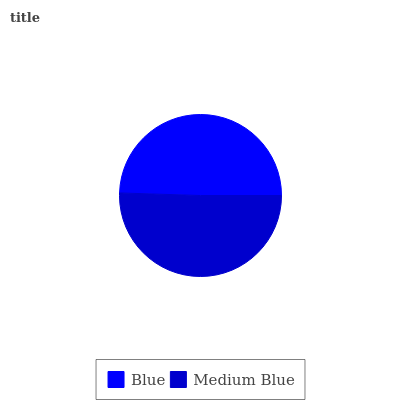Is Blue the minimum?
Answer yes or no. Yes. Is Medium Blue the maximum?
Answer yes or no. Yes. Is Medium Blue the minimum?
Answer yes or no. No. Is Medium Blue greater than Blue?
Answer yes or no. Yes. Is Blue less than Medium Blue?
Answer yes or no. Yes. Is Blue greater than Medium Blue?
Answer yes or no. No. Is Medium Blue less than Blue?
Answer yes or no. No. Is Medium Blue the high median?
Answer yes or no. Yes. Is Blue the low median?
Answer yes or no. Yes. Is Blue the high median?
Answer yes or no. No. Is Medium Blue the low median?
Answer yes or no. No. 